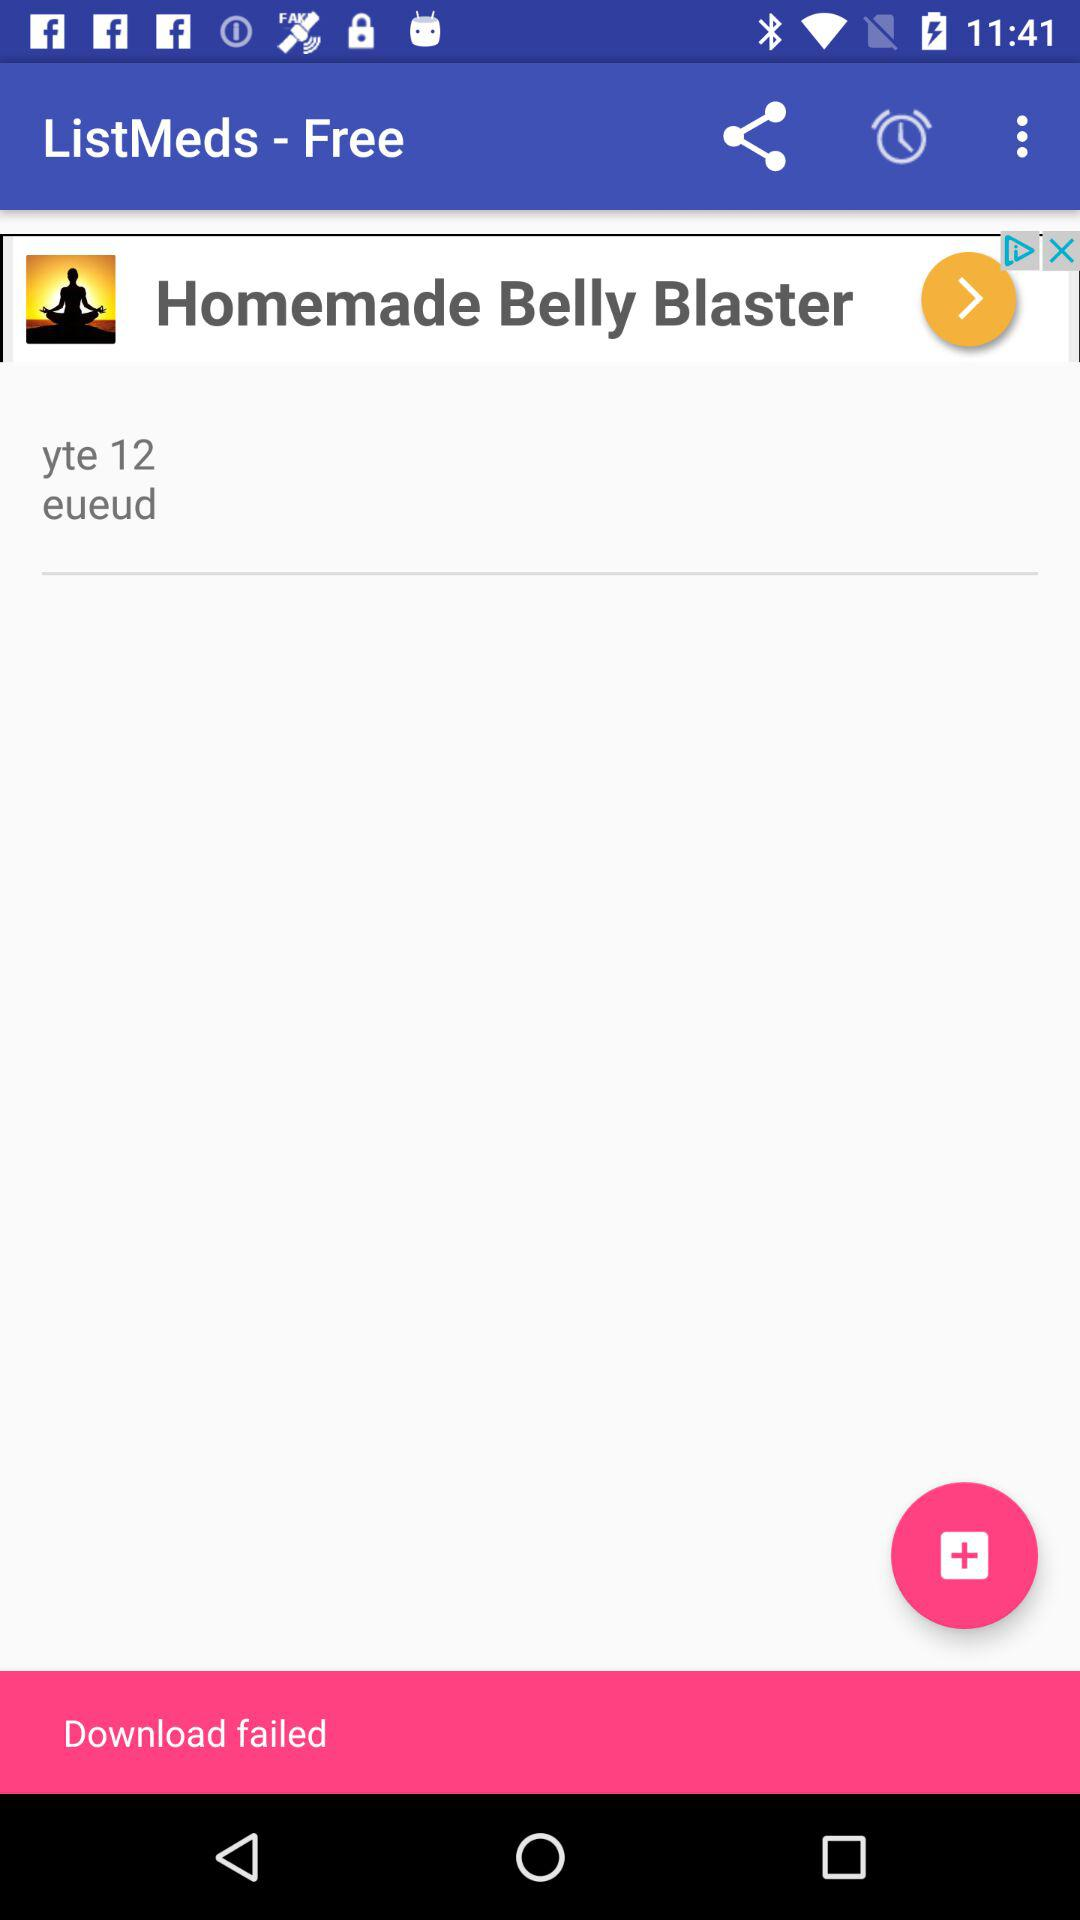Is the ListMeds app free or paid? The ListMeds app is "free". 